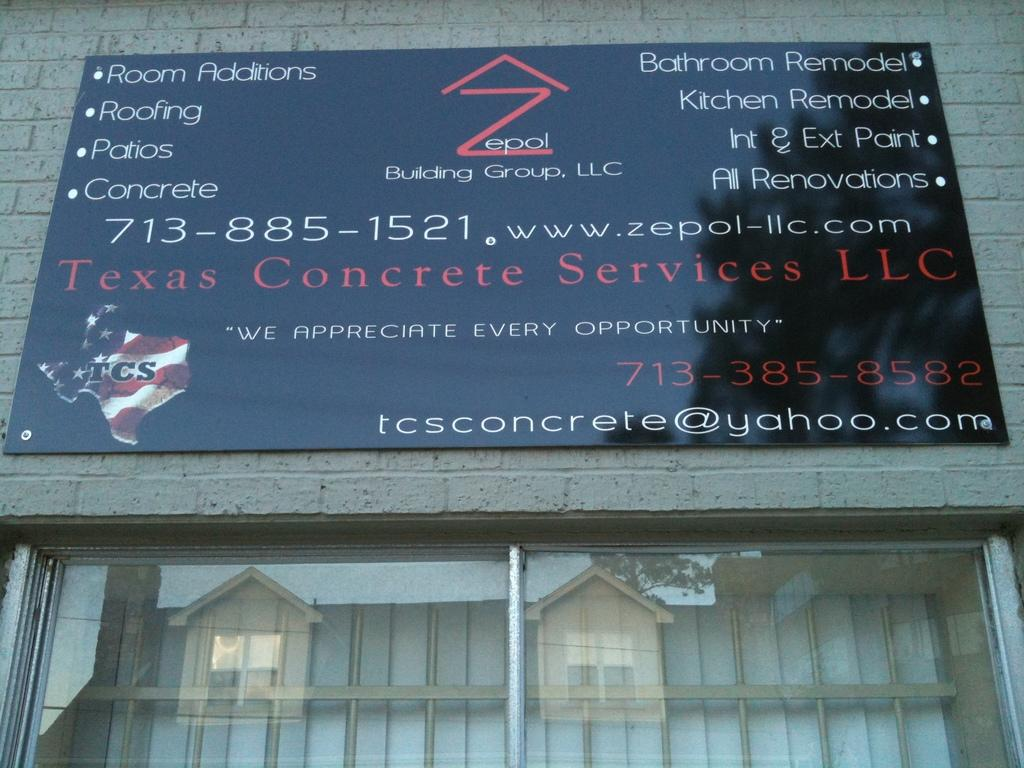What type of structure is visible in the image? There is a building in the image. What is written or displayed on the building? There is a board with text on the building. Can you describe any architectural features of the building? There is a window in the image. What can be seen in the reflection on the window's glass? The window has a reflection of the building on its glass. What is the annual income of the organization depicted on the building in the image? There is no information about an organization or its income in the image. 